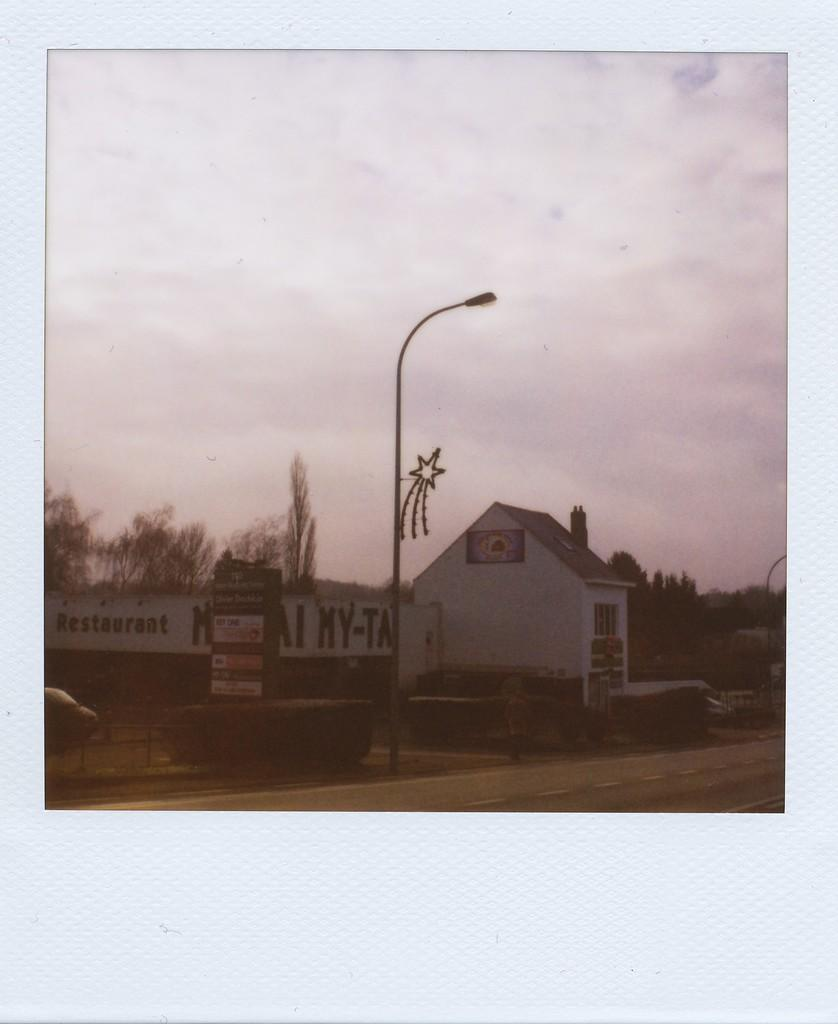What is the main structure in the middle of the image? There is a small house in the middle of the image. What else can be seen in the middle of the image besides the house? There is a light and trees in the middle of the image. What is visible at the top of the image? The sky is visible at the top of the image. How many ants are crawling on the vase in the image? There is no vase or ants present in the image. What rule is being enforced by the person in the image? There is no person or rule mentioned in the image. 